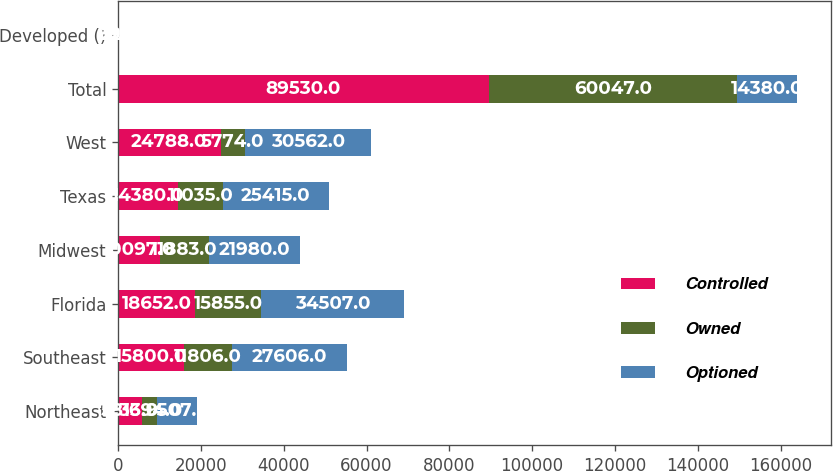<chart> <loc_0><loc_0><loc_500><loc_500><stacked_bar_chart><ecel><fcel>Northeast<fcel>Southeast<fcel>Florida<fcel>Midwest<fcel>Texas<fcel>West<fcel>Total<fcel>Developed ()<nl><fcel>Controlled<fcel>5813<fcel>15800<fcel>18652<fcel>10097<fcel>14380<fcel>24788<fcel>89530<fcel>39<nl><fcel>Owned<fcel>3694<fcel>11806<fcel>15855<fcel>11883<fcel>11035<fcel>5774<fcel>60047<fcel>21<nl><fcel>Optioned<fcel>9507<fcel>27606<fcel>34507<fcel>21980<fcel>25415<fcel>30562<fcel>14380<fcel>32<nl></chart> 